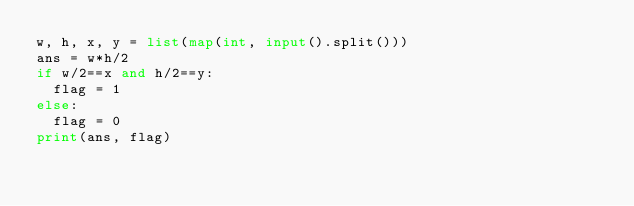Convert code to text. <code><loc_0><loc_0><loc_500><loc_500><_Python_>w, h, x, y = list(map(int, input().split()))
ans = w*h/2
if w/2==x and h/2==y:
  flag = 1
else:
  flag = 0
print(ans, flag)</code> 